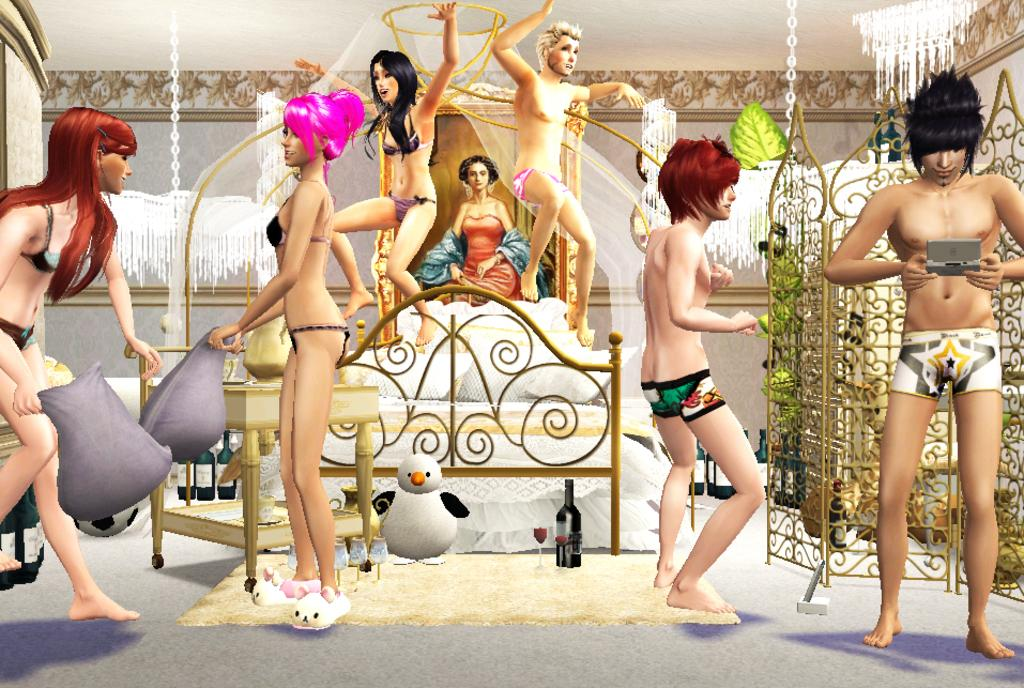What can be seen in the image? There are depictions of people in the image. What is visible in the background of the image? There is a bed, a table, and other objects in the background of the image. Can you describe the objects on the table? The provided facts do not give specific details about the objects on the table. What is attached to the wall in the background of the image? There is a photo frame attached to the wall in the background of the image. What language is spoken by the people in the image? The provided facts do not give any information about the language spoken by the people in the image. 